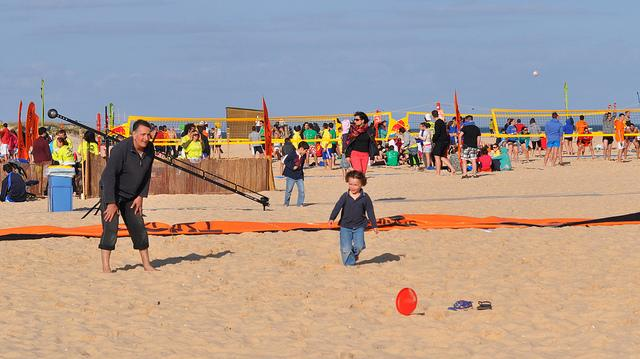What do they want to prevent the ball from touching? Please explain your reasoning. sand. The goal is to keep the ball in the air. 